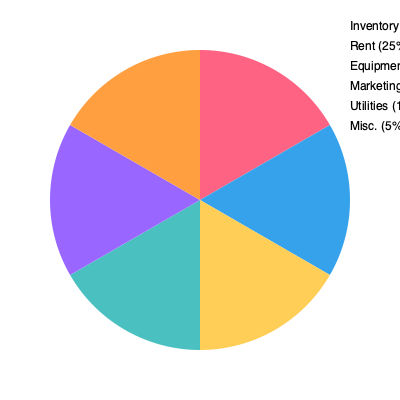Based on the pie chart showing the allocation of startup costs for a new retail business, if the total startup budget is $200,000, how much is allocated for equipment and marketing combined? To solve this problem, we need to follow these steps:

1. Identify the percentages for equipment and marketing from the pie chart:
   - Equipment: 20%
   - Marketing: 10%

2. Add these percentages together:
   20% + 10% = 30%

3. Calculate 30% of the total startup budget:
   $200,000 × 30% = $200,000 × 0.30 = $60,000

Therefore, the amount allocated for equipment and marketing combined is $60,000.

We can verify this by calculating each category separately:
- Equipment: $200,000 × 20% = $40,000
- Marketing: $200,000 × 10% = $20,000
$40,000 + $20,000 = $60,000

This confirms our calculation.
Answer: $60,000 